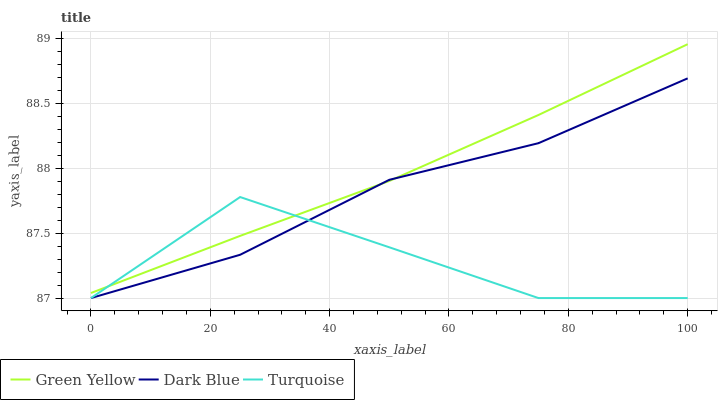Does Turquoise have the minimum area under the curve?
Answer yes or no. Yes. Does Green Yellow have the maximum area under the curve?
Answer yes or no. Yes. Does Green Yellow have the minimum area under the curve?
Answer yes or no. No. Does Turquoise have the maximum area under the curve?
Answer yes or no. No. Is Green Yellow the smoothest?
Answer yes or no. Yes. Is Turquoise the roughest?
Answer yes or no. Yes. Is Turquoise the smoothest?
Answer yes or no. No. Is Green Yellow the roughest?
Answer yes or no. No. Does Dark Blue have the lowest value?
Answer yes or no. Yes. Does Green Yellow have the lowest value?
Answer yes or no. No. Does Green Yellow have the highest value?
Answer yes or no. Yes. Does Turquoise have the highest value?
Answer yes or no. No. Does Green Yellow intersect Turquoise?
Answer yes or no. Yes. Is Green Yellow less than Turquoise?
Answer yes or no. No. Is Green Yellow greater than Turquoise?
Answer yes or no. No. 